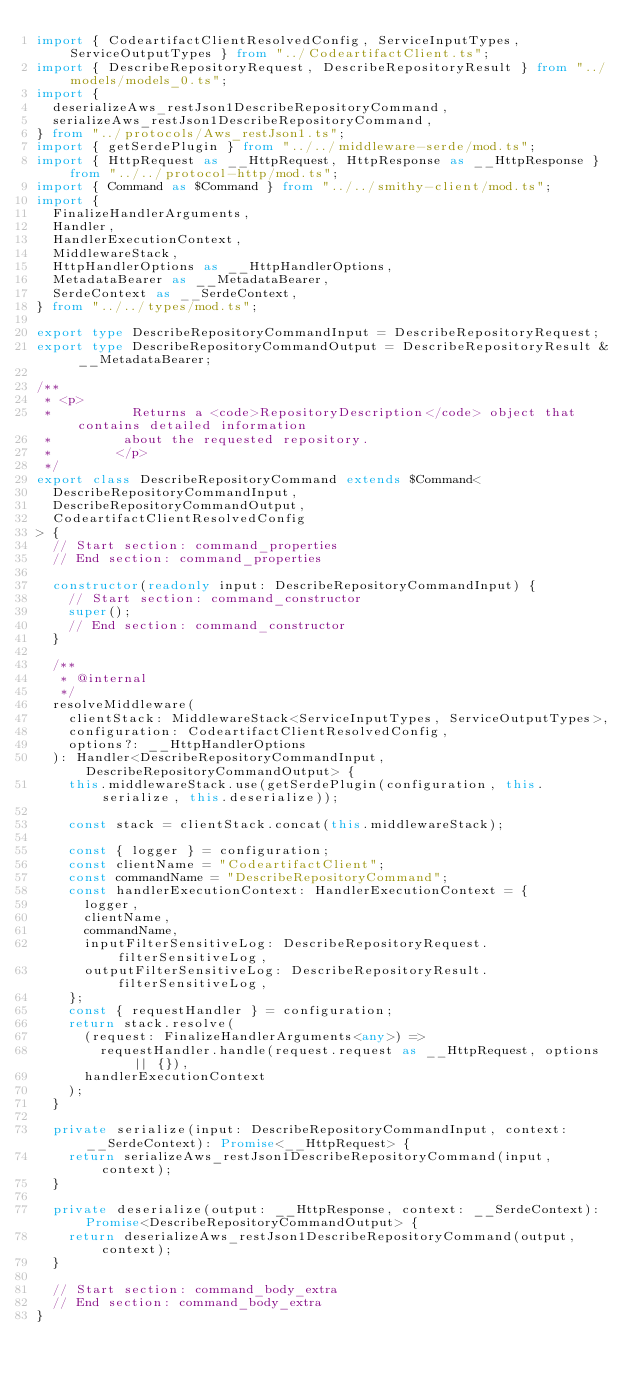Convert code to text. <code><loc_0><loc_0><loc_500><loc_500><_TypeScript_>import { CodeartifactClientResolvedConfig, ServiceInputTypes, ServiceOutputTypes } from "../CodeartifactClient.ts";
import { DescribeRepositoryRequest, DescribeRepositoryResult } from "../models/models_0.ts";
import {
  deserializeAws_restJson1DescribeRepositoryCommand,
  serializeAws_restJson1DescribeRepositoryCommand,
} from "../protocols/Aws_restJson1.ts";
import { getSerdePlugin } from "../../middleware-serde/mod.ts";
import { HttpRequest as __HttpRequest, HttpResponse as __HttpResponse } from "../../protocol-http/mod.ts";
import { Command as $Command } from "../../smithy-client/mod.ts";
import {
  FinalizeHandlerArguments,
  Handler,
  HandlerExecutionContext,
  MiddlewareStack,
  HttpHandlerOptions as __HttpHandlerOptions,
  MetadataBearer as __MetadataBearer,
  SerdeContext as __SerdeContext,
} from "../../types/mod.ts";

export type DescribeRepositoryCommandInput = DescribeRepositoryRequest;
export type DescribeRepositoryCommandOutput = DescribeRepositoryResult & __MetadataBearer;

/**
 * <p>
 *          Returns a <code>RepositoryDescription</code> object that contains detailed information
 *         about the requested repository.
 *        </p>
 */
export class DescribeRepositoryCommand extends $Command<
  DescribeRepositoryCommandInput,
  DescribeRepositoryCommandOutput,
  CodeartifactClientResolvedConfig
> {
  // Start section: command_properties
  // End section: command_properties

  constructor(readonly input: DescribeRepositoryCommandInput) {
    // Start section: command_constructor
    super();
    // End section: command_constructor
  }

  /**
   * @internal
   */
  resolveMiddleware(
    clientStack: MiddlewareStack<ServiceInputTypes, ServiceOutputTypes>,
    configuration: CodeartifactClientResolvedConfig,
    options?: __HttpHandlerOptions
  ): Handler<DescribeRepositoryCommandInput, DescribeRepositoryCommandOutput> {
    this.middlewareStack.use(getSerdePlugin(configuration, this.serialize, this.deserialize));

    const stack = clientStack.concat(this.middlewareStack);

    const { logger } = configuration;
    const clientName = "CodeartifactClient";
    const commandName = "DescribeRepositoryCommand";
    const handlerExecutionContext: HandlerExecutionContext = {
      logger,
      clientName,
      commandName,
      inputFilterSensitiveLog: DescribeRepositoryRequest.filterSensitiveLog,
      outputFilterSensitiveLog: DescribeRepositoryResult.filterSensitiveLog,
    };
    const { requestHandler } = configuration;
    return stack.resolve(
      (request: FinalizeHandlerArguments<any>) =>
        requestHandler.handle(request.request as __HttpRequest, options || {}),
      handlerExecutionContext
    );
  }

  private serialize(input: DescribeRepositoryCommandInput, context: __SerdeContext): Promise<__HttpRequest> {
    return serializeAws_restJson1DescribeRepositoryCommand(input, context);
  }

  private deserialize(output: __HttpResponse, context: __SerdeContext): Promise<DescribeRepositoryCommandOutput> {
    return deserializeAws_restJson1DescribeRepositoryCommand(output, context);
  }

  // Start section: command_body_extra
  // End section: command_body_extra
}
</code> 